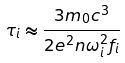<formula> <loc_0><loc_0><loc_500><loc_500>\tau _ { i } \approx \frac { 3 m _ { 0 } c ^ { 3 } } { 2 e ^ { 2 } n \omega _ { i } ^ { 2 } f _ { i } }</formula> 